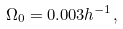Convert formula to latex. <formula><loc_0><loc_0><loc_500><loc_500>\Omega _ { 0 } = 0 . 0 0 3 h ^ { - 1 } ,</formula> 